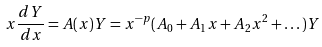Convert formula to latex. <formula><loc_0><loc_0><loc_500><loc_500>x \frac { d Y } { d x } = A ( x ) Y = x ^ { - p } ( A _ { 0 } + A _ { 1 } x + A _ { 2 } x ^ { 2 } + \dots ) Y</formula> 